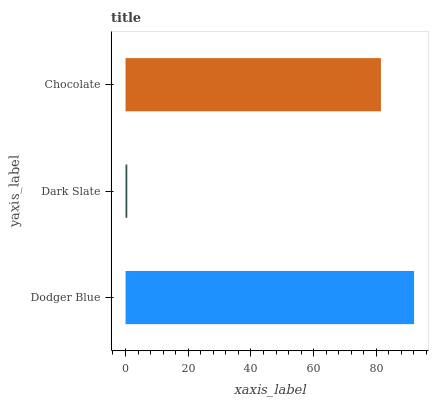Is Dark Slate the minimum?
Answer yes or no. Yes. Is Dodger Blue the maximum?
Answer yes or no. Yes. Is Chocolate the minimum?
Answer yes or no. No. Is Chocolate the maximum?
Answer yes or no. No. Is Chocolate greater than Dark Slate?
Answer yes or no. Yes. Is Dark Slate less than Chocolate?
Answer yes or no. Yes. Is Dark Slate greater than Chocolate?
Answer yes or no. No. Is Chocolate less than Dark Slate?
Answer yes or no. No. Is Chocolate the high median?
Answer yes or no. Yes. Is Chocolate the low median?
Answer yes or no. Yes. Is Dodger Blue the high median?
Answer yes or no. No. Is Dodger Blue the low median?
Answer yes or no. No. 